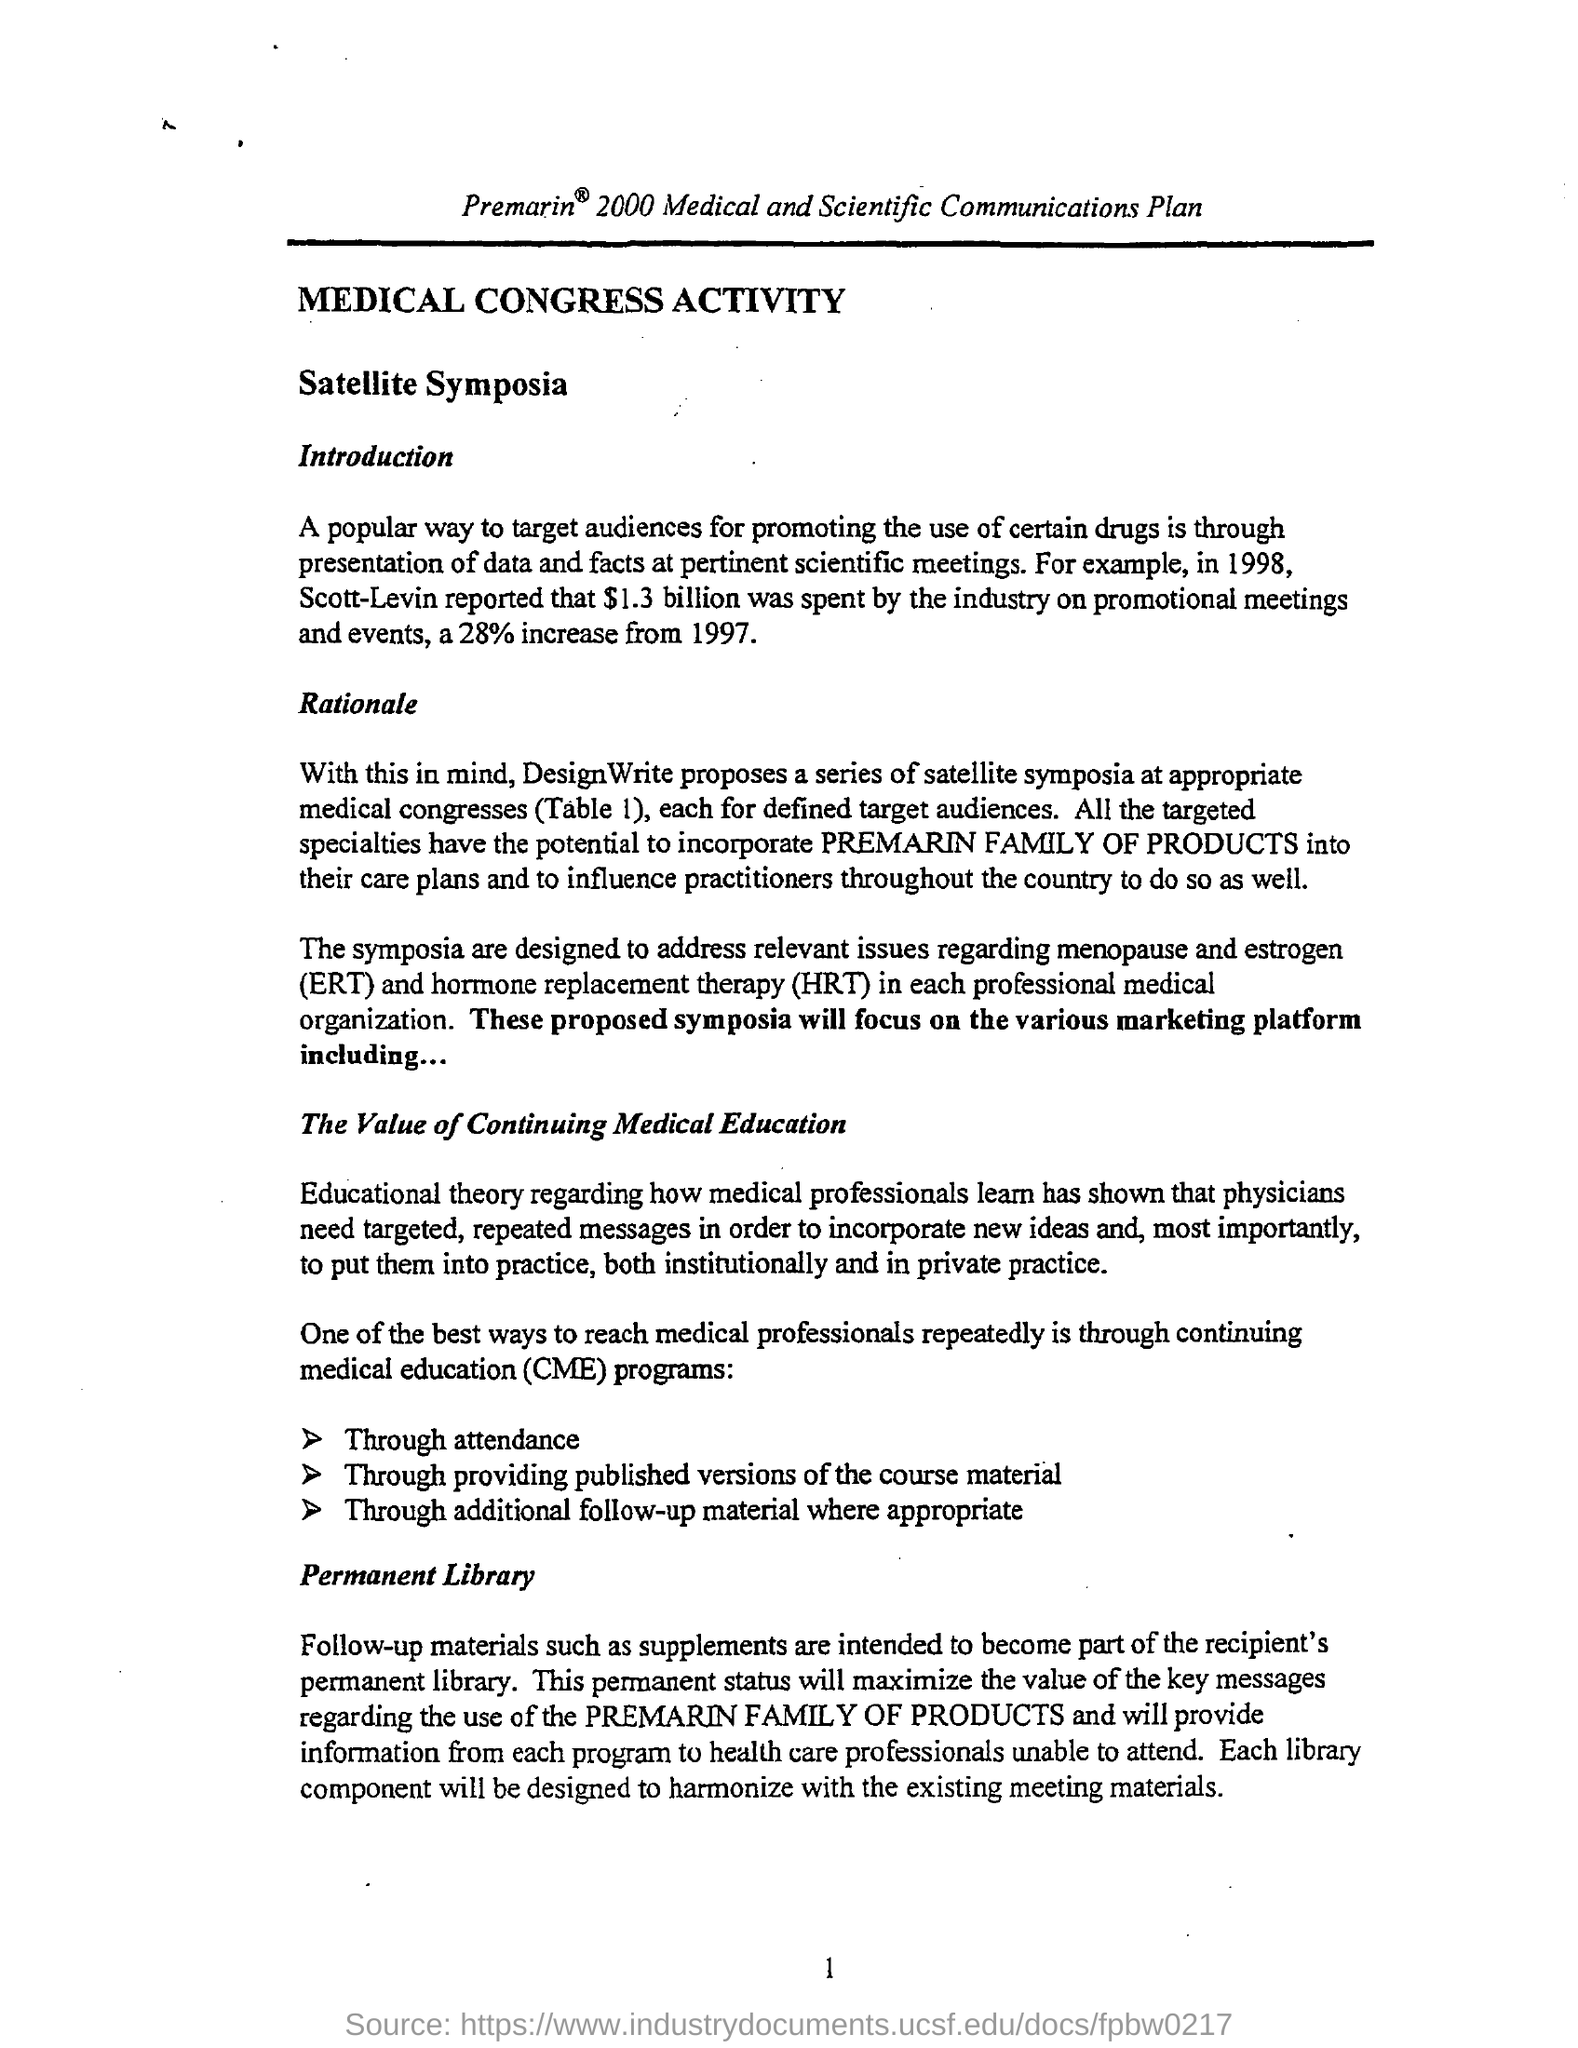What is the fullform of HRT?
Your response must be concise. Hormone replacement therapy. What is intended to become part of the recipient's permanent library?
Your answer should be very brief. Follow-up materials such as supplements. Which Company proposes a series of satellite symposia at appropriate medical congress (Table 1), each for defined target audiences?
Offer a terse response. DesignWrite. 